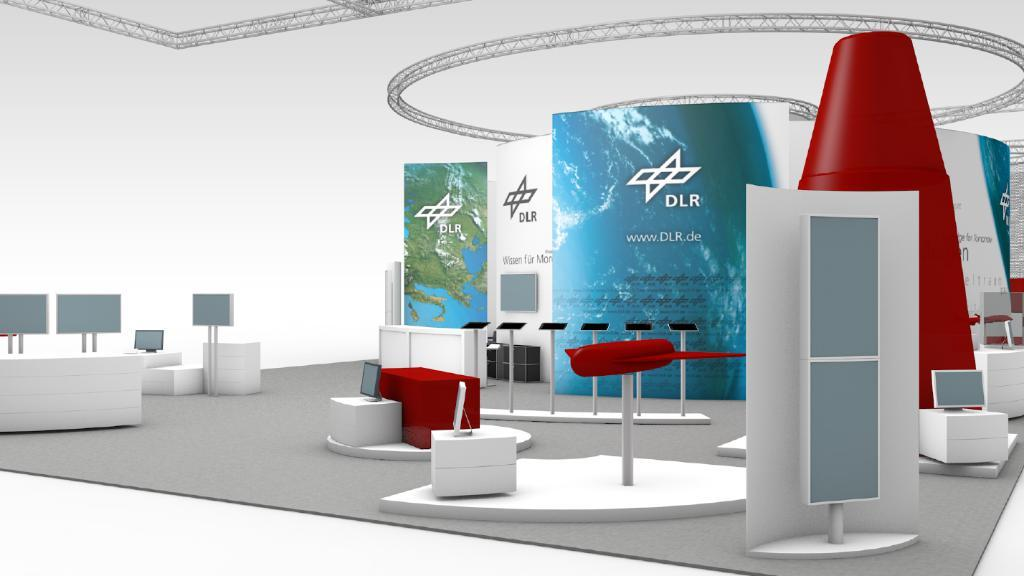What type of furniture is present in the image? There are tables in the image. What is placed on the tables? There are systems on the tables. What else can be seen in the image besides the tables and systems? There are boards with stands and posters in the image in the background. Are there any specific colors present in the image? Yes, there are red color objects in the image. What committee is meeting in the image? There is no committee meeting in the image; it only shows tables, systems, boards with stands, posters, and red color objects. Can you see any zippers on the systems in the image? There are no zippers visible in the image. 